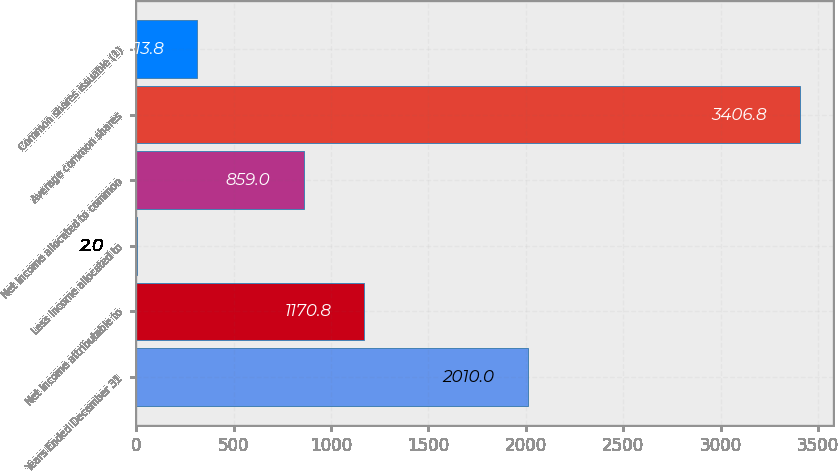Convert chart to OTSL. <chart><loc_0><loc_0><loc_500><loc_500><bar_chart><fcel>Years Ended December 31<fcel>Net income attributable to<fcel>Less Income allocated to<fcel>Net income allocated to common<fcel>Average common shares<fcel>Common shares issuable (1)<nl><fcel>2010<fcel>1170.8<fcel>2<fcel>859<fcel>3406.8<fcel>313.8<nl></chart> 